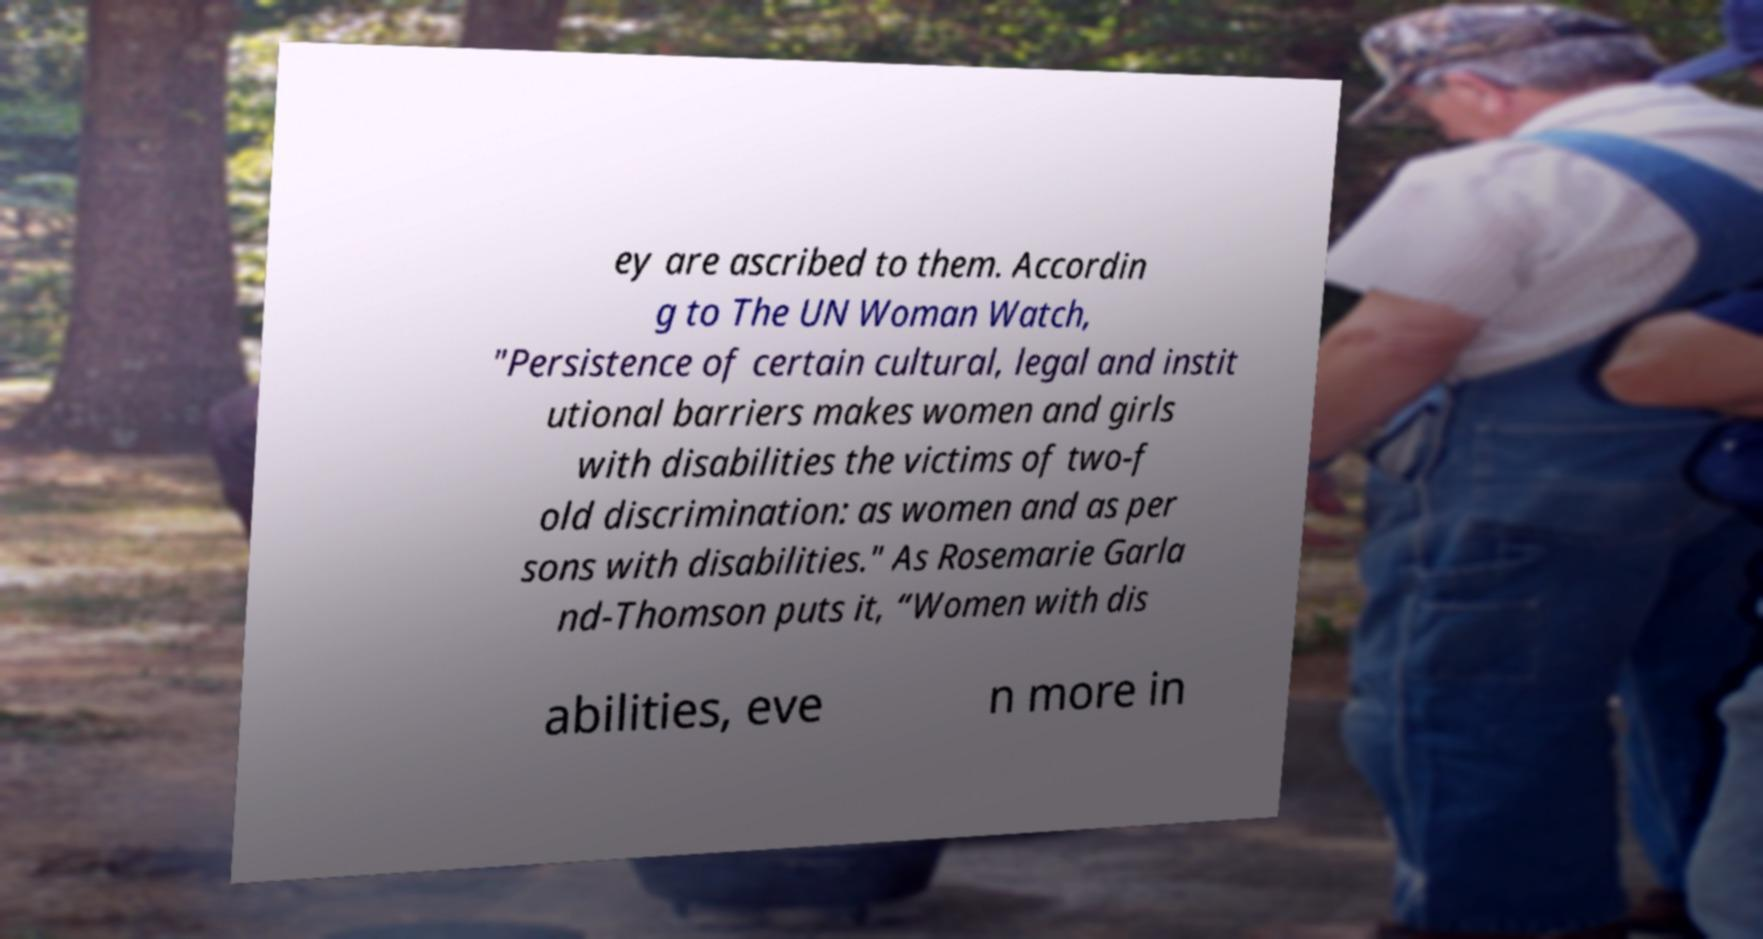Please read and relay the text visible in this image. What does it say? ey are ascribed to them. Accordin g to The UN Woman Watch, "Persistence of certain cultural, legal and instit utional barriers makes women and girls with disabilities the victims of two-f old discrimination: as women and as per sons with disabilities." As Rosemarie Garla nd-Thomson puts it, “Women with dis abilities, eve n more in 